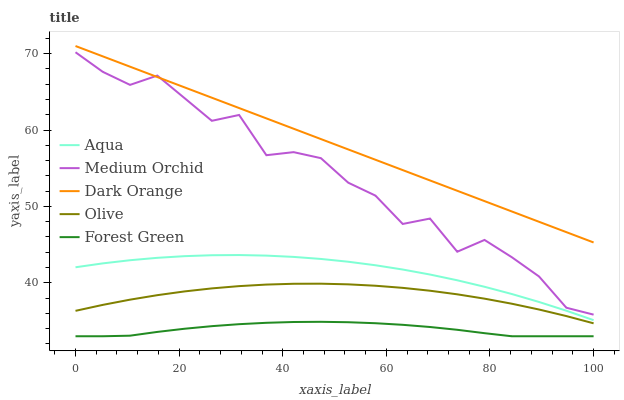Does Forest Green have the minimum area under the curve?
Answer yes or no. Yes. Does Dark Orange have the maximum area under the curve?
Answer yes or no. Yes. Does Dark Orange have the minimum area under the curve?
Answer yes or no. No. Does Forest Green have the maximum area under the curve?
Answer yes or no. No. Is Dark Orange the smoothest?
Answer yes or no. Yes. Is Medium Orchid the roughest?
Answer yes or no. Yes. Is Forest Green the smoothest?
Answer yes or no. No. Is Forest Green the roughest?
Answer yes or no. No. Does Forest Green have the lowest value?
Answer yes or no. Yes. Does Dark Orange have the lowest value?
Answer yes or no. No. Does Dark Orange have the highest value?
Answer yes or no. Yes. Does Forest Green have the highest value?
Answer yes or no. No. Is Olive less than Dark Orange?
Answer yes or no. Yes. Is Medium Orchid greater than Aqua?
Answer yes or no. Yes. Does Medium Orchid intersect Dark Orange?
Answer yes or no. Yes. Is Medium Orchid less than Dark Orange?
Answer yes or no. No. Is Medium Orchid greater than Dark Orange?
Answer yes or no. No. Does Olive intersect Dark Orange?
Answer yes or no. No. 